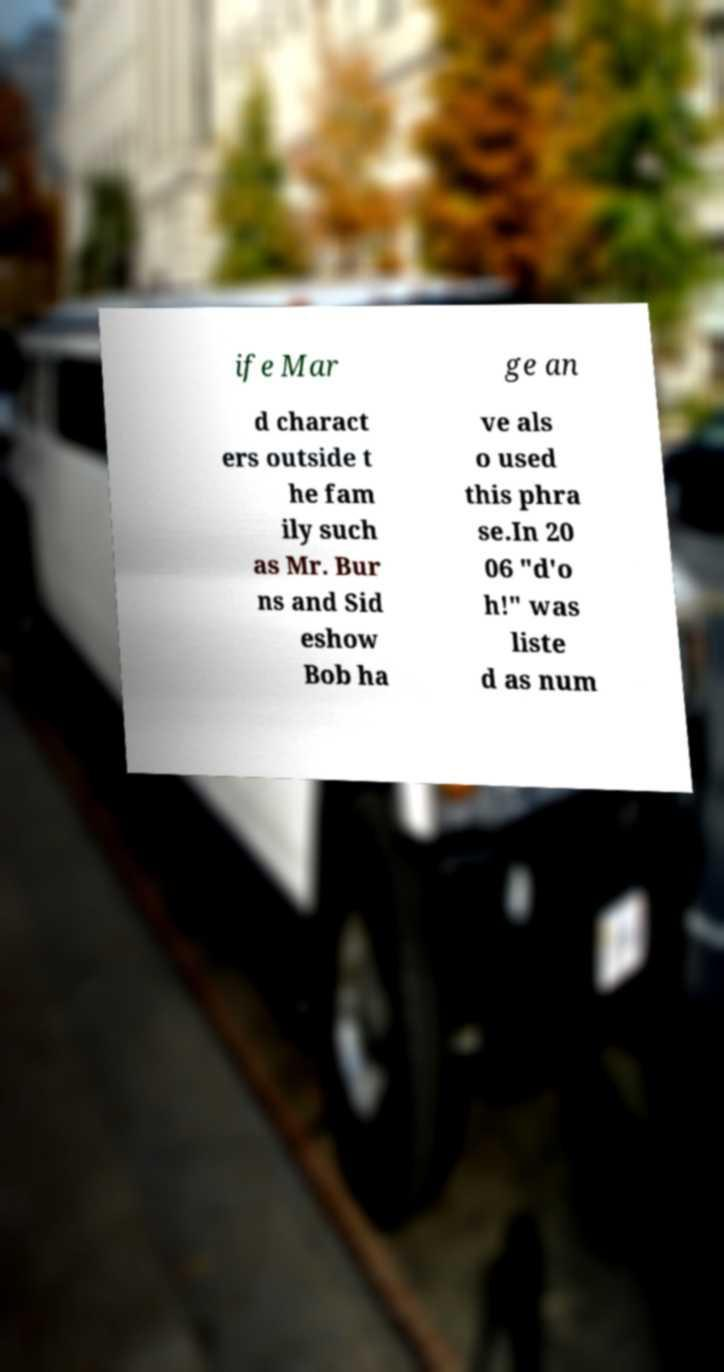Please identify and transcribe the text found in this image. ife Mar ge an d charact ers outside t he fam ily such as Mr. Bur ns and Sid eshow Bob ha ve als o used this phra se.In 20 06 "d'o h!" was liste d as num 